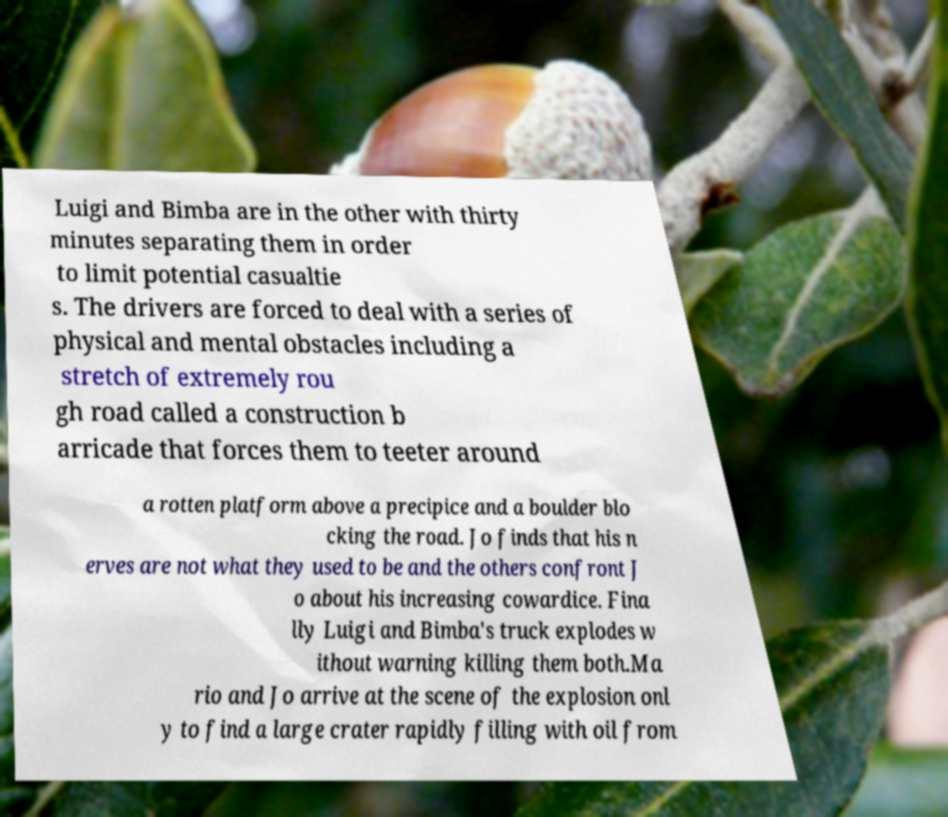Can you read and provide the text displayed in the image?This photo seems to have some interesting text. Can you extract and type it out for me? Luigi and Bimba are in the other with thirty minutes separating them in order to limit potential casualtie s. The drivers are forced to deal with a series of physical and mental obstacles including a stretch of extremely rou gh road called a construction b arricade that forces them to teeter around a rotten platform above a precipice and a boulder blo cking the road. Jo finds that his n erves are not what they used to be and the others confront J o about his increasing cowardice. Fina lly Luigi and Bimba's truck explodes w ithout warning killing them both.Ma rio and Jo arrive at the scene of the explosion onl y to find a large crater rapidly filling with oil from 